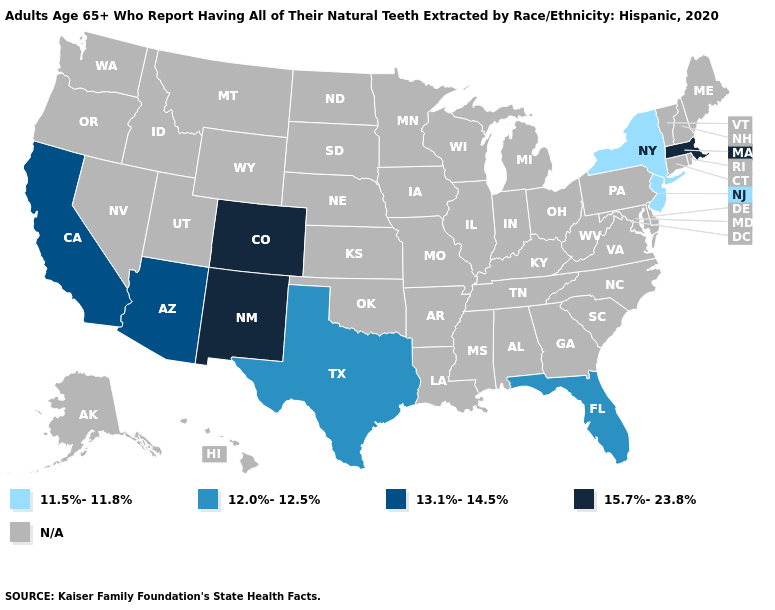What is the value of Massachusetts?
Answer briefly. 15.7%-23.8%. Does New Mexico have the highest value in the USA?
Be succinct. Yes. What is the value of New Mexico?
Answer briefly. 15.7%-23.8%. Name the states that have a value in the range 12.0%-12.5%?
Be succinct. Florida, Texas. What is the value of Michigan?
Write a very short answer. N/A. What is the highest value in states that border Utah?
Short answer required. 15.7%-23.8%. Does Texas have the highest value in the USA?
Concise answer only. No. Name the states that have a value in the range 13.1%-14.5%?
Give a very brief answer. Arizona, California. What is the value of Delaware?
Quick response, please. N/A. Name the states that have a value in the range 11.5%-11.8%?
Write a very short answer. New Jersey, New York. What is the highest value in the USA?
Concise answer only. 15.7%-23.8%. What is the lowest value in the South?
Answer briefly. 12.0%-12.5%. 